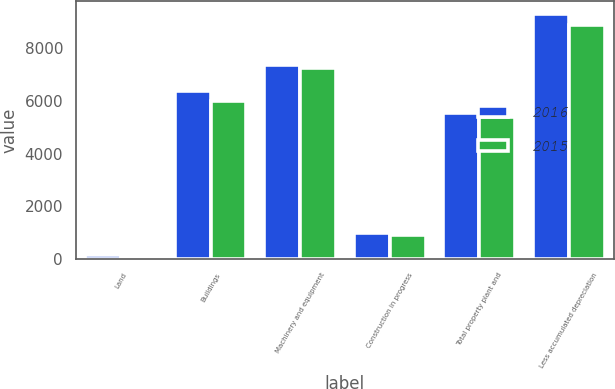<chart> <loc_0><loc_0><loc_500><loc_500><stacked_bar_chart><ecel><fcel>Land<fcel>Buildings<fcel>Machinery and equipment<fcel>Construction in progress<fcel>Total property plant and<fcel>Less accumulated depreciation<nl><fcel>2016<fcel>127<fcel>6385<fcel>7389<fcel>976<fcel>5549<fcel>9328<nl><fcel>2015<fcel>112<fcel>6007<fcel>7261<fcel>886<fcel>5389<fcel>8877<nl></chart> 